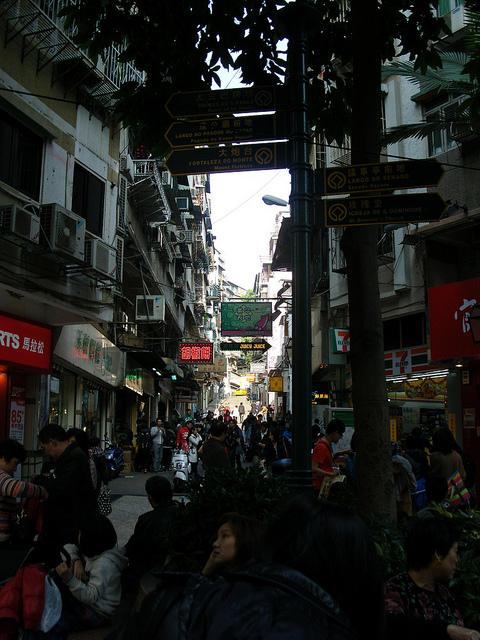How many shelves are on the rack?
Be succinct. 0. Is it nighttime or daytime?
Quick response, please. Daytime. Is this street busy?
Answer briefly. Yes. What is the name of the Running Store in the background?
Answer briefly. Nike. What fast food restaurant is there a sign for?
Concise answer only. 0. Why are the air conditioning units on the second story of the buildings on the left?
Concise answer only. Apartments. 